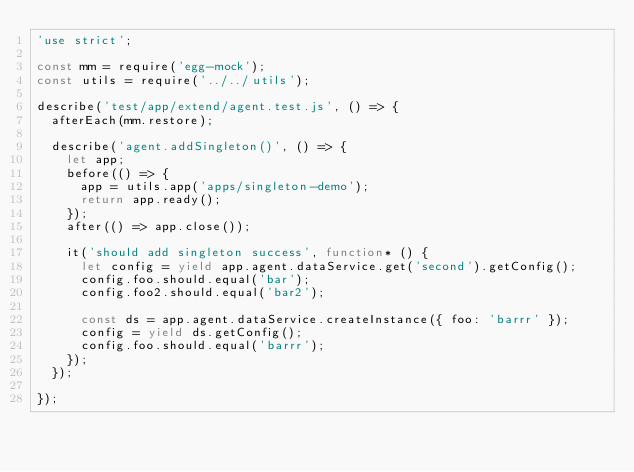<code> <loc_0><loc_0><loc_500><loc_500><_JavaScript_>'use strict';

const mm = require('egg-mock');
const utils = require('../../utils');

describe('test/app/extend/agent.test.js', () => {
  afterEach(mm.restore);

  describe('agent.addSingleton()', () => {
    let app;
    before(() => {
      app = utils.app('apps/singleton-demo');
      return app.ready();
    });
    after(() => app.close());

    it('should add singleton success', function* () {
      let config = yield app.agent.dataService.get('second').getConfig();
      config.foo.should.equal('bar');
      config.foo2.should.equal('bar2');

      const ds = app.agent.dataService.createInstance({ foo: 'barrr' });
      config = yield ds.getConfig();
      config.foo.should.equal('barrr');
    });
  });

});
</code> 